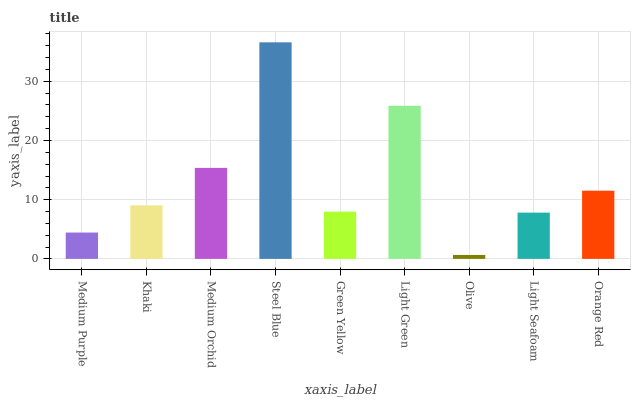Is Olive the minimum?
Answer yes or no. Yes. Is Steel Blue the maximum?
Answer yes or no. Yes. Is Khaki the minimum?
Answer yes or no. No. Is Khaki the maximum?
Answer yes or no. No. Is Khaki greater than Medium Purple?
Answer yes or no. Yes. Is Medium Purple less than Khaki?
Answer yes or no. Yes. Is Medium Purple greater than Khaki?
Answer yes or no. No. Is Khaki less than Medium Purple?
Answer yes or no. No. Is Khaki the high median?
Answer yes or no. Yes. Is Khaki the low median?
Answer yes or no. Yes. Is Medium Orchid the high median?
Answer yes or no. No. Is Light Seafoam the low median?
Answer yes or no. No. 